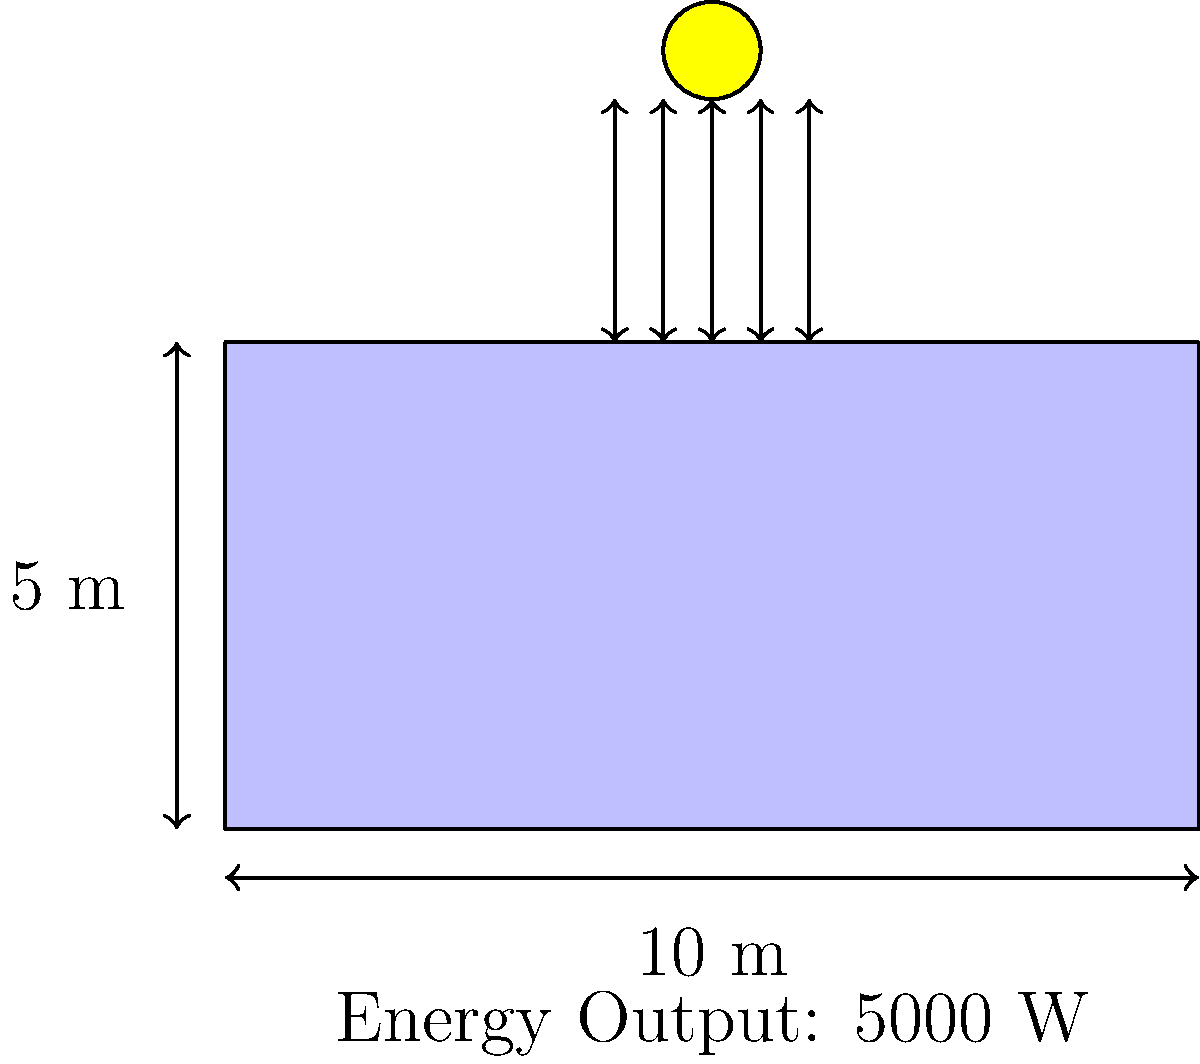As a retiree interested in sustainable investments, you're considering installing a solar panel array on your property. Given the solar panel array shown in the diagram with dimensions 10 m x 5 m and an energy output of 5000 W, calculate its efficiency if the incident solar radiation is 1000 W/m². How does this efficiency compare to typical commercial solar panels, and what ethical considerations should you keep in mind when choosing solar technology? To calculate the efficiency of the solar panel array, we'll follow these steps:

1. Calculate the area of the solar panel array:
   Area = length × width = 10 m × 5 m = 50 m²

2. Calculate the total incident solar power:
   Incident power = solar radiation × area
   = 1000 W/m² × 50 m² = 50,000 W

3. Calculate the efficiency:
   Efficiency = (Output power / Incident power) × 100%
   = (5000 W / 50,000 W) × 100% = 10%

The efficiency of this solar panel array is 10%.

Typical commercial solar panels have efficiencies ranging from 15% to 22%. The calculated efficiency of 10% is lower than the average commercial solar panel.

Ethical considerations for choosing solar technology:
1. Environmental impact: Manufacturing process and materials used
2. Labor practices: Ensuring fair working conditions in production
3. Recycling and end-of-life disposal: Minimizing waste and environmental harm
4. Sourcing of materials: Avoiding conflict minerals and supporting responsible mining
5. Energy payback time: Ensuring the panel produces more energy than consumed in its production
6. Local economic impact: Supporting local businesses and job creation
7. Long-term sustainability: Choosing durable and efficient technologies

These considerations align with ethical investing principles, balancing financial returns with positive social and environmental impacts.
Answer: 10% efficiency; below average for commercial panels. Consider environmental impact, labor practices, recycling, responsible sourcing, energy payback, local impact, and long-term sustainability. 